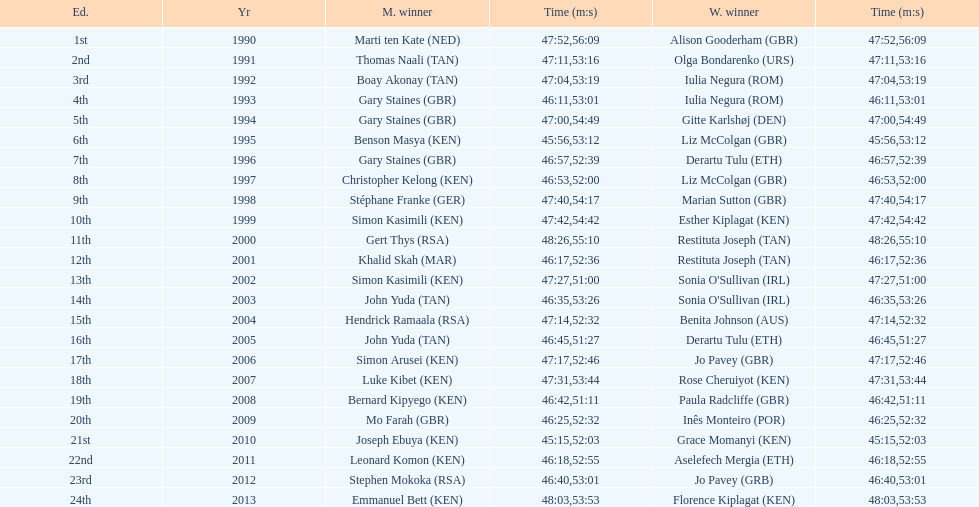For the 2013 bupa great south run, what are the differences in finishing times between men's and women's categories? 5:50. 